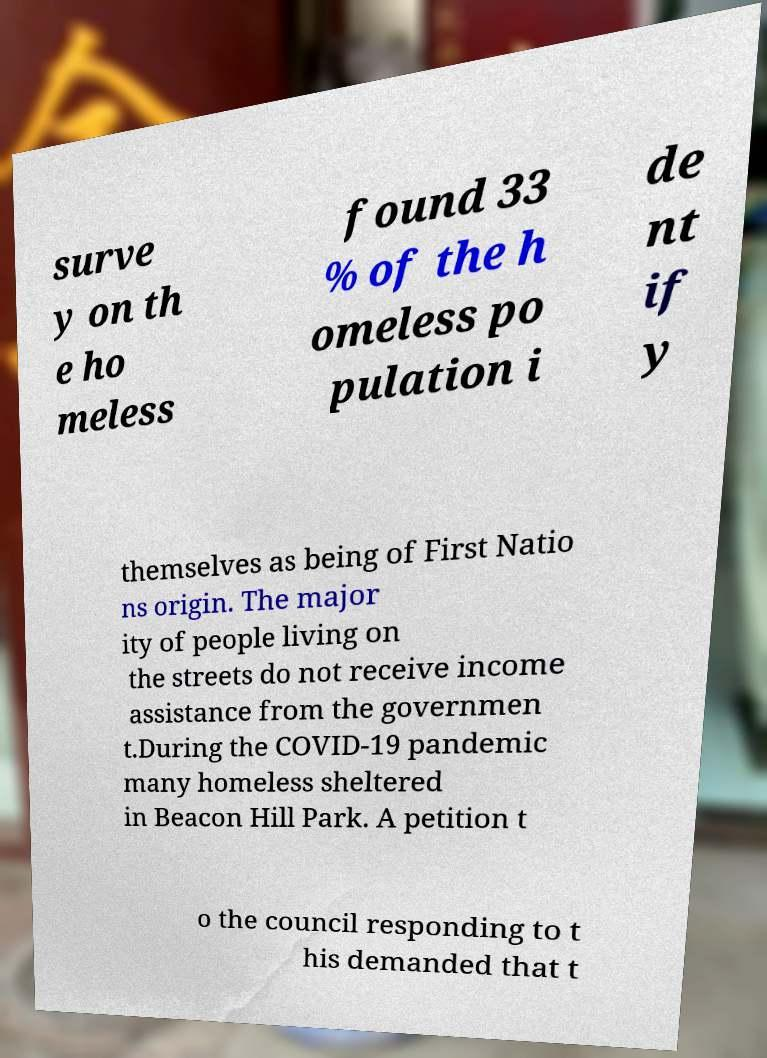What messages or text are displayed in this image? I need them in a readable, typed format. surve y on th e ho meless found 33 % of the h omeless po pulation i de nt if y themselves as being of First Natio ns origin. The major ity of people living on the streets do not receive income assistance from the governmen t.During the COVID-19 pandemic many homeless sheltered in Beacon Hill Park. A petition t o the council responding to t his demanded that t 